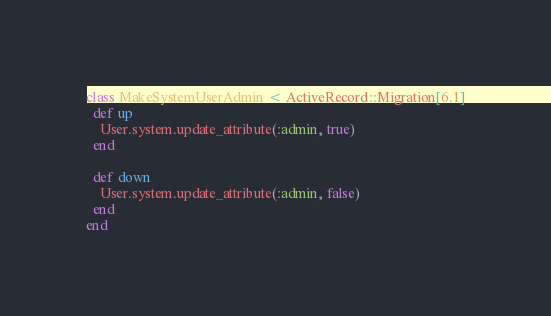<code> <loc_0><loc_0><loc_500><loc_500><_Ruby_>class MakeSystemUserAdmin < ActiveRecord::Migration[6.1]
  def up
    User.system.update_attribute(:admin, true)
  end

  def down
    User.system.update_attribute(:admin, false)
  end
end
</code> 